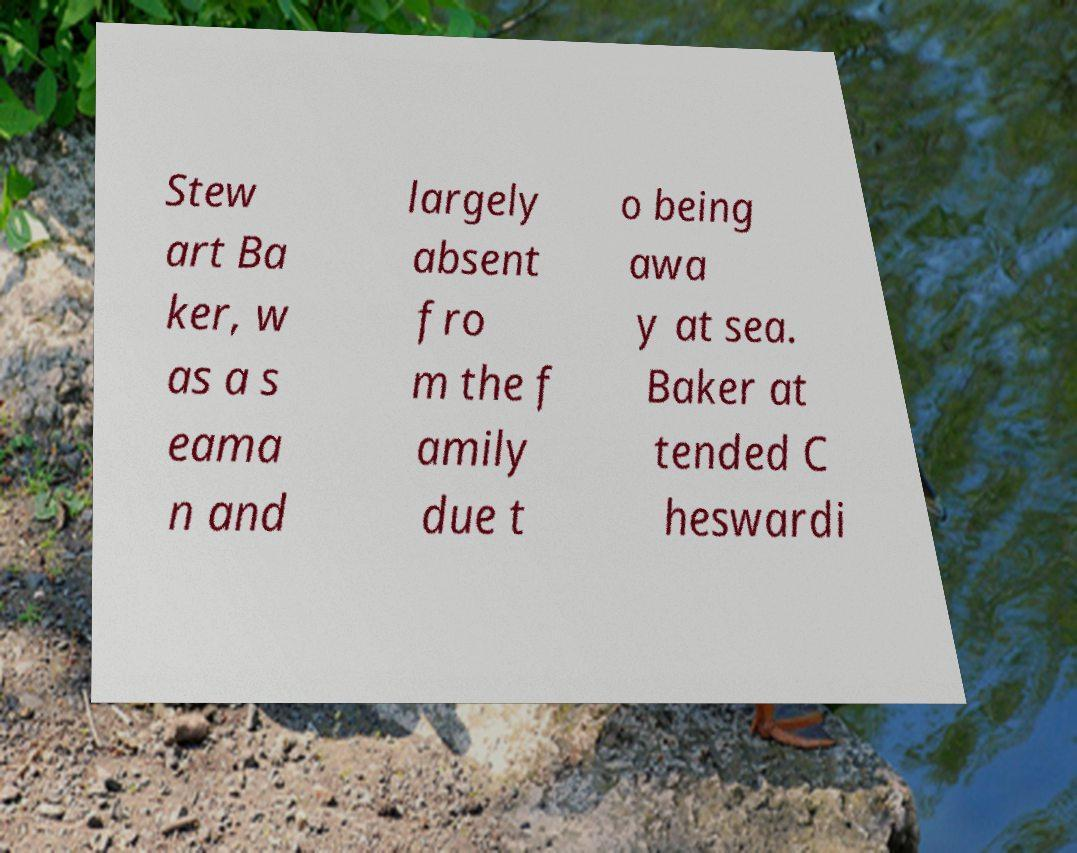Could you extract and type out the text from this image? Stew art Ba ker, w as a s eama n and largely absent fro m the f amily due t o being awa y at sea. Baker at tended C heswardi 